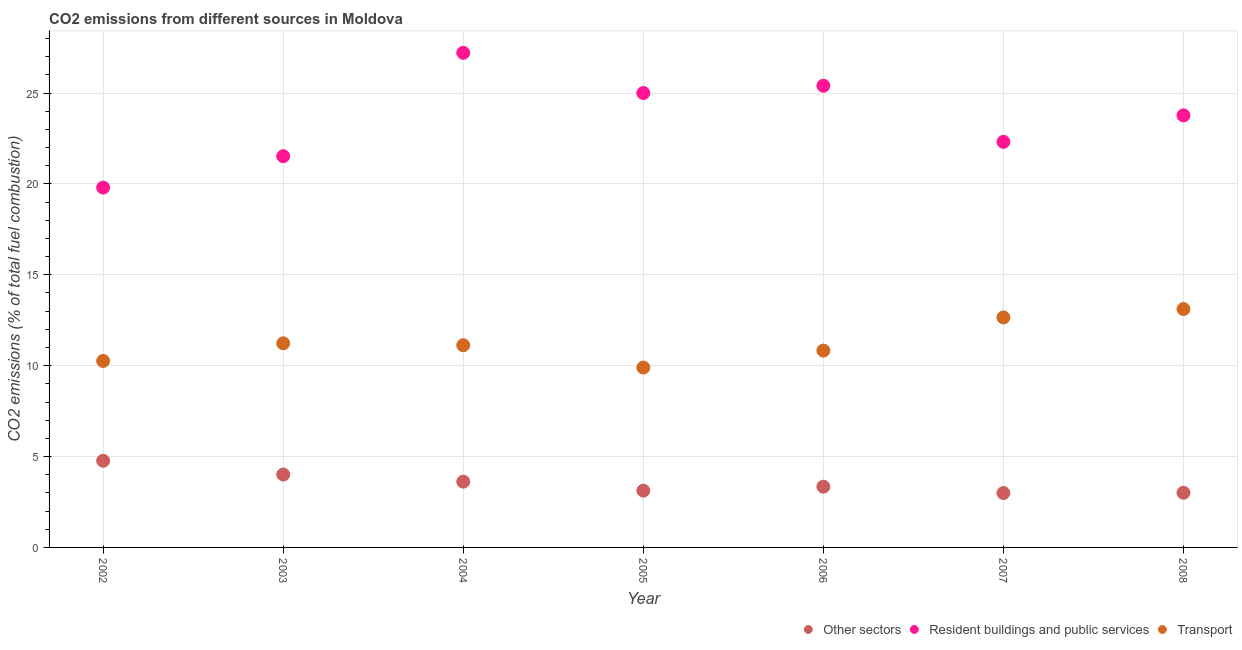How many different coloured dotlines are there?
Keep it short and to the point. 3. What is the percentage of co2 emissions from other sectors in 2004?
Give a very brief answer. 3.62. Across all years, what is the maximum percentage of co2 emissions from resident buildings and public services?
Your response must be concise. 27.21. Across all years, what is the minimum percentage of co2 emissions from other sectors?
Make the answer very short. 2.99. What is the total percentage of co2 emissions from transport in the graph?
Your response must be concise. 79.11. What is the difference between the percentage of co2 emissions from resident buildings and public services in 2004 and that in 2006?
Give a very brief answer. 1.81. What is the difference between the percentage of co2 emissions from resident buildings and public services in 2003 and the percentage of co2 emissions from transport in 2002?
Make the answer very short. 11.26. What is the average percentage of co2 emissions from other sectors per year?
Offer a terse response. 3.55. In the year 2004, what is the difference between the percentage of co2 emissions from other sectors and percentage of co2 emissions from resident buildings and public services?
Ensure brevity in your answer.  -23.59. What is the ratio of the percentage of co2 emissions from resident buildings and public services in 2003 to that in 2004?
Provide a succinct answer. 0.79. Is the percentage of co2 emissions from other sectors in 2004 less than that in 2005?
Offer a very short reply. No. Is the difference between the percentage of co2 emissions from transport in 2003 and 2006 greater than the difference between the percentage of co2 emissions from other sectors in 2003 and 2006?
Offer a very short reply. No. What is the difference between the highest and the second highest percentage of co2 emissions from transport?
Ensure brevity in your answer.  0.46. What is the difference between the highest and the lowest percentage of co2 emissions from resident buildings and public services?
Give a very brief answer. 7.41. Is it the case that in every year, the sum of the percentage of co2 emissions from other sectors and percentage of co2 emissions from resident buildings and public services is greater than the percentage of co2 emissions from transport?
Provide a short and direct response. Yes. Is the percentage of co2 emissions from resident buildings and public services strictly greater than the percentage of co2 emissions from transport over the years?
Give a very brief answer. Yes. How many years are there in the graph?
Offer a terse response. 7. What is the difference between two consecutive major ticks on the Y-axis?
Provide a succinct answer. 5. Are the values on the major ticks of Y-axis written in scientific E-notation?
Give a very brief answer. No. Does the graph contain any zero values?
Keep it short and to the point. No. Where does the legend appear in the graph?
Offer a terse response. Bottom right. How many legend labels are there?
Make the answer very short. 3. How are the legend labels stacked?
Keep it short and to the point. Horizontal. What is the title of the graph?
Give a very brief answer. CO2 emissions from different sources in Moldova. Does "Ireland" appear as one of the legend labels in the graph?
Make the answer very short. No. What is the label or title of the X-axis?
Your answer should be very brief. Year. What is the label or title of the Y-axis?
Provide a succinct answer. CO2 emissions (% of total fuel combustion). What is the CO2 emissions (% of total fuel combustion) in Other sectors in 2002?
Keep it short and to the point. 4.77. What is the CO2 emissions (% of total fuel combustion) in Resident buildings and public services in 2002?
Give a very brief answer. 19.8. What is the CO2 emissions (% of total fuel combustion) of Transport in 2002?
Make the answer very short. 10.26. What is the CO2 emissions (% of total fuel combustion) in Other sectors in 2003?
Your answer should be compact. 4.01. What is the CO2 emissions (% of total fuel combustion) of Resident buildings and public services in 2003?
Give a very brief answer. 21.52. What is the CO2 emissions (% of total fuel combustion) of Transport in 2003?
Provide a succinct answer. 11.23. What is the CO2 emissions (% of total fuel combustion) in Other sectors in 2004?
Give a very brief answer. 3.62. What is the CO2 emissions (% of total fuel combustion) in Resident buildings and public services in 2004?
Provide a succinct answer. 27.21. What is the CO2 emissions (% of total fuel combustion) of Transport in 2004?
Provide a short and direct response. 11.13. What is the CO2 emissions (% of total fuel combustion) of Other sectors in 2005?
Your response must be concise. 3.12. What is the CO2 emissions (% of total fuel combustion) in Resident buildings and public services in 2005?
Your answer should be very brief. 25. What is the CO2 emissions (% of total fuel combustion) of Transport in 2005?
Ensure brevity in your answer.  9.9. What is the CO2 emissions (% of total fuel combustion) of Other sectors in 2006?
Make the answer very short. 3.34. What is the CO2 emissions (% of total fuel combustion) in Resident buildings and public services in 2006?
Ensure brevity in your answer.  25.4. What is the CO2 emissions (% of total fuel combustion) in Transport in 2006?
Your answer should be very brief. 10.83. What is the CO2 emissions (% of total fuel combustion) in Other sectors in 2007?
Offer a terse response. 2.99. What is the CO2 emissions (% of total fuel combustion) of Resident buildings and public services in 2007?
Your answer should be very brief. 22.31. What is the CO2 emissions (% of total fuel combustion) in Transport in 2007?
Offer a terse response. 12.65. What is the CO2 emissions (% of total fuel combustion) in Other sectors in 2008?
Provide a short and direct response. 3.01. What is the CO2 emissions (% of total fuel combustion) of Resident buildings and public services in 2008?
Provide a succinct answer. 23.77. What is the CO2 emissions (% of total fuel combustion) in Transport in 2008?
Your answer should be compact. 13.11. Across all years, what is the maximum CO2 emissions (% of total fuel combustion) of Other sectors?
Offer a terse response. 4.77. Across all years, what is the maximum CO2 emissions (% of total fuel combustion) of Resident buildings and public services?
Your answer should be compact. 27.21. Across all years, what is the maximum CO2 emissions (% of total fuel combustion) of Transport?
Keep it short and to the point. 13.11. Across all years, what is the minimum CO2 emissions (% of total fuel combustion) in Other sectors?
Make the answer very short. 2.99. Across all years, what is the minimum CO2 emissions (% of total fuel combustion) of Resident buildings and public services?
Offer a very short reply. 19.8. Across all years, what is the minimum CO2 emissions (% of total fuel combustion) in Transport?
Offer a very short reply. 9.9. What is the total CO2 emissions (% of total fuel combustion) in Other sectors in the graph?
Make the answer very short. 24.86. What is the total CO2 emissions (% of total fuel combustion) in Resident buildings and public services in the graph?
Keep it short and to the point. 165.02. What is the total CO2 emissions (% of total fuel combustion) of Transport in the graph?
Your answer should be very brief. 79.11. What is the difference between the CO2 emissions (% of total fuel combustion) in Other sectors in 2002 and that in 2003?
Offer a very short reply. 0.76. What is the difference between the CO2 emissions (% of total fuel combustion) of Resident buildings and public services in 2002 and that in 2003?
Provide a succinct answer. -1.73. What is the difference between the CO2 emissions (% of total fuel combustion) of Transport in 2002 and that in 2003?
Your answer should be compact. -0.97. What is the difference between the CO2 emissions (% of total fuel combustion) in Other sectors in 2002 and that in 2004?
Your answer should be very brief. 1.15. What is the difference between the CO2 emissions (% of total fuel combustion) in Resident buildings and public services in 2002 and that in 2004?
Keep it short and to the point. -7.41. What is the difference between the CO2 emissions (% of total fuel combustion) in Transport in 2002 and that in 2004?
Give a very brief answer. -0.87. What is the difference between the CO2 emissions (% of total fuel combustion) of Other sectors in 2002 and that in 2005?
Offer a terse response. 1.64. What is the difference between the CO2 emissions (% of total fuel combustion) of Resident buildings and public services in 2002 and that in 2005?
Keep it short and to the point. -5.2. What is the difference between the CO2 emissions (% of total fuel combustion) in Transport in 2002 and that in 2005?
Provide a succinct answer. 0.36. What is the difference between the CO2 emissions (% of total fuel combustion) of Other sectors in 2002 and that in 2006?
Give a very brief answer. 1.43. What is the difference between the CO2 emissions (% of total fuel combustion) of Resident buildings and public services in 2002 and that in 2006?
Offer a terse response. -5.6. What is the difference between the CO2 emissions (% of total fuel combustion) of Transport in 2002 and that in 2006?
Keep it short and to the point. -0.57. What is the difference between the CO2 emissions (% of total fuel combustion) in Other sectors in 2002 and that in 2007?
Your answer should be very brief. 1.78. What is the difference between the CO2 emissions (% of total fuel combustion) in Resident buildings and public services in 2002 and that in 2007?
Offer a very short reply. -2.52. What is the difference between the CO2 emissions (% of total fuel combustion) in Transport in 2002 and that in 2007?
Give a very brief answer. -2.39. What is the difference between the CO2 emissions (% of total fuel combustion) in Other sectors in 2002 and that in 2008?
Your answer should be very brief. 1.76. What is the difference between the CO2 emissions (% of total fuel combustion) of Resident buildings and public services in 2002 and that in 2008?
Offer a very short reply. -3.97. What is the difference between the CO2 emissions (% of total fuel combustion) in Transport in 2002 and that in 2008?
Your answer should be compact. -2.85. What is the difference between the CO2 emissions (% of total fuel combustion) of Other sectors in 2003 and that in 2004?
Offer a very short reply. 0.39. What is the difference between the CO2 emissions (% of total fuel combustion) in Resident buildings and public services in 2003 and that in 2004?
Give a very brief answer. -5.69. What is the difference between the CO2 emissions (% of total fuel combustion) of Transport in 2003 and that in 2004?
Your answer should be very brief. 0.1. What is the difference between the CO2 emissions (% of total fuel combustion) of Other sectors in 2003 and that in 2005?
Make the answer very short. 0.89. What is the difference between the CO2 emissions (% of total fuel combustion) of Resident buildings and public services in 2003 and that in 2005?
Provide a short and direct response. -3.48. What is the difference between the CO2 emissions (% of total fuel combustion) in Transport in 2003 and that in 2005?
Provide a short and direct response. 1.33. What is the difference between the CO2 emissions (% of total fuel combustion) of Other sectors in 2003 and that in 2006?
Provide a succinct answer. 0.67. What is the difference between the CO2 emissions (% of total fuel combustion) of Resident buildings and public services in 2003 and that in 2006?
Provide a short and direct response. -3.88. What is the difference between the CO2 emissions (% of total fuel combustion) in Transport in 2003 and that in 2006?
Give a very brief answer. 0.4. What is the difference between the CO2 emissions (% of total fuel combustion) of Other sectors in 2003 and that in 2007?
Give a very brief answer. 1.02. What is the difference between the CO2 emissions (% of total fuel combustion) of Resident buildings and public services in 2003 and that in 2007?
Offer a terse response. -0.79. What is the difference between the CO2 emissions (% of total fuel combustion) in Transport in 2003 and that in 2007?
Give a very brief answer. -1.42. What is the difference between the CO2 emissions (% of total fuel combustion) of Other sectors in 2003 and that in 2008?
Ensure brevity in your answer.  1.01. What is the difference between the CO2 emissions (% of total fuel combustion) in Resident buildings and public services in 2003 and that in 2008?
Give a very brief answer. -2.25. What is the difference between the CO2 emissions (% of total fuel combustion) of Transport in 2003 and that in 2008?
Make the answer very short. -1.88. What is the difference between the CO2 emissions (% of total fuel combustion) in Other sectors in 2004 and that in 2005?
Give a very brief answer. 0.49. What is the difference between the CO2 emissions (% of total fuel combustion) in Resident buildings and public services in 2004 and that in 2005?
Ensure brevity in your answer.  2.21. What is the difference between the CO2 emissions (% of total fuel combustion) in Transport in 2004 and that in 2005?
Ensure brevity in your answer.  1.23. What is the difference between the CO2 emissions (% of total fuel combustion) in Other sectors in 2004 and that in 2006?
Provide a succinct answer. 0.28. What is the difference between the CO2 emissions (% of total fuel combustion) in Resident buildings and public services in 2004 and that in 2006?
Give a very brief answer. 1.81. What is the difference between the CO2 emissions (% of total fuel combustion) in Transport in 2004 and that in 2006?
Ensure brevity in your answer.  0.3. What is the difference between the CO2 emissions (% of total fuel combustion) in Other sectors in 2004 and that in 2007?
Make the answer very short. 0.63. What is the difference between the CO2 emissions (% of total fuel combustion) of Resident buildings and public services in 2004 and that in 2007?
Provide a short and direct response. 4.9. What is the difference between the CO2 emissions (% of total fuel combustion) of Transport in 2004 and that in 2007?
Ensure brevity in your answer.  -1.53. What is the difference between the CO2 emissions (% of total fuel combustion) of Other sectors in 2004 and that in 2008?
Your response must be concise. 0.61. What is the difference between the CO2 emissions (% of total fuel combustion) in Resident buildings and public services in 2004 and that in 2008?
Offer a very short reply. 3.44. What is the difference between the CO2 emissions (% of total fuel combustion) of Transport in 2004 and that in 2008?
Provide a succinct answer. -1.99. What is the difference between the CO2 emissions (% of total fuel combustion) in Other sectors in 2005 and that in 2006?
Keep it short and to the point. -0.22. What is the difference between the CO2 emissions (% of total fuel combustion) of Resident buildings and public services in 2005 and that in 2006?
Give a very brief answer. -0.4. What is the difference between the CO2 emissions (% of total fuel combustion) of Transport in 2005 and that in 2006?
Provide a short and direct response. -0.93. What is the difference between the CO2 emissions (% of total fuel combustion) in Other sectors in 2005 and that in 2007?
Your answer should be very brief. 0.13. What is the difference between the CO2 emissions (% of total fuel combustion) of Resident buildings and public services in 2005 and that in 2007?
Offer a terse response. 2.69. What is the difference between the CO2 emissions (% of total fuel combustion) in Transport in 2005 and that in 2007?
Give a very brief answer. -2.76. What is the difference between the CO2 emissions (% of total fuel combustion) of Other sectors in 2005 and that in 2008?
Ensure brevity in your answer.  0.12. What is the difference between the CO2 emissions (% of total fuel combustion) in Resident buildings and public services in 2005 and that in 2008?
Keep it short and to the point. 1.23. What is the difference between the CO2 emissions (% of total fuel combustion) in Transport in 2005 and that in 2008?
Your answer should be very brief. -3.22. What is the difference between the CO2 emissions (% of total fuel combustion) of Other sectors in 2006 and that in 2007?
Offer a terse response. 0.35. What is the difference between the CO2 emissions (% of total fuel combustion) in Resident buildings and public services in 2006 and that in 2007?
Ensure brevity in your answer.  3.09. What is the difference between the CO2 emissions (% of total fuel combustion) of Transport in 2006 and that in 2007?
Your answer should be compact. -1.82. What is the difference between the CO2 emissions (% of total fuel combustion) in Other sectors in 2006 and that in 2008?
Provide a short and direct response. 0.34. What is the difference between the CO2 emissions (% of total fuel combustion) in Resident buildings and public services in 2006 and that in 2008?
Offer a terse response. 1.63. What is the difference between the CO2 emissions (% of total fuel combustion) of Transport in 2006 and that in 2008?
Your answer should be very brief. -2.29. What is the difference between the CO2 emissions (% of total fuel combustion) of Other sectors in 2007 and that in 2008?
Your answer should be compact. -0.01. What is the difference between the CO2 emissions (% of total fuel combustion) in Resident buildings and public services in 2007 and that in 2008?
Provide a succinct answer. -1.46. What is the difference between the CO2 emissions (% of total fuel combustion) in Transport in 2007 and that in 2008?
Give a very brief answer. -0.46. What is the difference between the CO2 emissions (% of total fuel combustion) in Other sectors in 2002 and the CO2 emissions (% of total fuel combustion) in Resident buildings and public services in 2003?
Offer a terse response. -16.76. What is the difference between the CO2 emissions (% of total fuel combustion) of Other sectors in 2002 and the CO2 emissions (% of total fuel combustion) of Transport in 2003?
Offer a very short reply. -6.46. What is the difference between the CO2 emissions (% of total fuel combustion) of Resident buildings and public services in 2002 and the CO2 emissions (% of total fuel combustion) of Transport in 2003?
Your response must be concise. 8.57. What is the difference between the CO2 emissions (% of total fuel combustion) in Other sectors in 2002 and the CO2 emissions (% of total fuel combustion) in Resident buildings and public services in 2004?
Offer a very short reply. -22.44. What is the difference between the CO2 emissions (% of total fuel combustion) of Other sectors in 2002 and the CO2 emissions (% of total fuel combustion) of Transport in 2004?
Keep it short and to the point. -6.36. What is the difference between the CO2 emissions (% of total fuel combustion) in Resident buildings and public services in 2002 and the CO2 emissions (% of total fuel combustion) in Transport in 2004?
Your response must be concise. 8.67. What is the difference between the CO2 emissions (% of total fuel combustion) of Other sectors in 2002 and the CO2 emissions (% of total fuel combustion) of Resident buildings and public services in 2005?
Your response must be concise. -20.23. What is the difference between the CO2 emissions (% of total fuel combustion) in Other sectors in 2002 and the CO2 emissions (% of total fuel combustion) in Transport in 2005?
Give a very brief answer. -5.13. What is the difference between the CO2 emissions (% of total fuel combustion) of Resident buildings and public services in 2002 and the CO2 emissions (% of total fuel combustion) of Transport in 2005?
Keep it short and to the point. 9.9. What is the difference between the CO2 emissions (% of total fuel combustion) of Other sectors in 2002 and the CO2 emissions (% of total fuel combustion) of Resident buildings and public services in 2006?
Provide a short and direct response. -20.63. What is the difference between the CO2 emissions (% of total fuel combustion) in Other sectors in 2002 and the CO2 emissions (% of total fuel combustion) in Transport in 2006?
Offer a very short reply. -6.06. What is the difference between the CO2 emissions (% of total fuel combustion) in Resident buildings and public services in 2002 and the CO2 emissions (% of total fuel combustion) in Transport in 2006?
Make the answer very short. 8.97. What is the difference between the CO2 emissions (% of total fuel combustion) of Other sectors in 2002 and the CO2 emissions (% of total fuel combustion) of Resident buildings and public services in 2007?
Your answer should be very brief. -17.54. What is the difference between the CO2 emissions (% of total fuel combustion) in Other sectors in 2002 and the CO2 emissions (% of total fuel combustion) in Transport in 2007?
Give a very brief answer. -7.88. What is the difference between the CO2 emissions (% of total fuel combustion) in Resident buildings and public services in 2002 and the CO2 emissions (% of total fuel combustion) in Transport in 2007?
Give a very brief answer. 7.14. What is the difference between the CO2 emissions (% of total fuel combustion) of Other sectors in 2002 and the CO2 emissions (% of total fuel combustion) of Resident buildings and public services in 2008?
Your answer should be compact. -19. What is the difference between the CO2 emissions (% of total fuel combustion) of Other sectors in 2002 and the CO2 emissions (% of total fuel combustion) of Transport in 2008?
Give a very brief answer. -8.35. What is the difference between the CO2 emissions (% of total fuel combustion) in Resident buildings and public services in 2002 and the CO2 emissions (% of total fuel combustion) in Transport in 2008?
Give a very brief answer. 6.68. What is the difference between the CO2 emissions (% of total fuel combustion) in Other sectors in 2003 and the CO2 emissions (% of total fuel combustion) in Resident buildings and public services in 2004?
Offer a very short reply. -23.2. What is the difference between the CO2 emissions (% of total fuel combustion) of Other sectors in 2003 and the CO2 emissions (% of total fuel combustion) of Transport in 2004?
Offer a very short reply. -7.12. What is the difference between the CO2 emissions (% of total fuel combustion) of Resident buildings and public services in 2003 and the CO2 emissions (% of total fuel combustion) of Transport in 2004?
Your answer should be compact. 10.4. What is the difference between the CO2 emissions (% of total fuel combustion) in Other sectors in 2003 and the CO2 emissions (% of total fuel combustion) in Resident buildings and public services in 2005?
Your answer should be compact. -20.99. What is the difference between the CO2 emissions (% of total fuel combustion) of Other sectors in 2003 and the CO2 emissions (% of total fuel combustion) of Transport in 2005?
Your response must be concise. -5.89. What is the difference between the CO2 emissions (% of total fuel combustion) of Resident buildings and public services in 2003 and the CO2 emissions (% of total fuel combustion) of Transport in 2005?
Make the answer very short. 11.63. What is the difference between the CO2 emissions (% of total fuel combustion) of Other sectors in 2003 and the CO2 emissions (% of total fuel combustion) of Resident buildings and public services in 2006?
Ensure brevity in your answer.  -21.39. What is the difference between the CO2 emissions (% of total fuel combustion) of Other sectors in 2003 and the CO2 emissions (% of total fuel combustion) of Transport in 2006?
Give a very brief answer. -6.82. What is the difference between the CO2 emissions (% of total fuel combustion) of Resident buildings and public services in 2003 and the CO2 emissions (% of total fuel combustion) of Transport in 2006?
Give a very brief answer. 10.7. What is the difference between the CO2 emissions (% of total fuel combustion) in Other sectors in 2003 and the CO2 emissions (% of total fuel combustion) in Resident buildings and public services in 2007?
Give a very brief answer. -18.3. What is the difference between the CO2 emissions (% of total fuel combustion) of Other sectors in 2003 and the CO2 emissions (% of total fuel combustion) of Transport in 2007?
Your answer should be compact. -8.64. What is the difference between the CO2 emissions (% of total fuel combustion) of Resident buildings and public services in 2003 and the CO2 emissions (% of total fuel combustion) of Transport in 2007?
Keep it short and to the point. 8.87. What is the difference between the CO2 emissions (% of total fuel combustion) of Other sectors in 2003 and the CO2 emissions (% of total fuel combustion) of Resident buildings and public services in 2008?
Your answer should be very brief. -19.76. What is the difference between the CO2 emissions (% of total fuel combustion) of Other sectors in 2003 and the CO2 emissions (% of total fuel combustion) of Transport in 2008?
Ensure brevity in your answer.  -9.1. What is the difference between the CO2 emissions (% of total fuel combustion) in Resident buildings and public services in 2003 and the CO2 emissions (% of total fuel combustion) in Transport in 2008?
Your answer should be very brief. 8.41. What is the difference between the CO2 emissions (% of total fuel combustion) of Other sectors in 2004 and the CO2 emissions (% of total fuel combustion) of Resident buildings and public services in 2005?
Offer a very short reply. -21.38. What is the difference between the CO2 emissions (% of total fuel combustion) of Other sectors in 2004 and the CO2 emissions (% of total fuel combustion) of Transport in 2005?
Ensure brevity in your answer.  -6.28. What is the difference between the CO2 emissions (% of total fuel combustion) in Resident buildings and public services in 2004 and the CO2 emissions (% of total fuel combustion) in Transport in 2005?
Keep it short and to the point. 17.32. What is the difference between the CO2 emissions (% of total fuel combustion) of Other sectors in 2004 and the CO2 emissions (% of total fuel combustion) of Resident buildings and public services in 2006?
Ensure brevity in your answer.  -21.78. What is the difference between the CO2 emissions (% of total fuel combustion) in Other sectors in 2004 and the CO2 emissions (% of total fuel combustion) in Transport in 2006?
Make the answer very short. -7.21. What is the difference between the CO2 emissions (% of total fuel combustion) of Resident buildings and public services in 2004 and the CO2 emissions (% of total fuel combustion) of Transport in 2006?
Provide a succinct answer. 16.38. What is the difference between the CO2 emissions (% of total fuel combustion) of Other sectors in 2004 and the CO2 emissions (% of total fuel combustion) of Resident buildings and public services in 2007?
Offer a terse response. -18.69. What is the difference between the CO2 emissions (% of total fuel combustion) in Other sectors in 2004 and the CO2 emissions (% of total fuel combustion) in Transport in 2007?
Give a very brief answer. -9.03. What is the difference between the CO2 emissions (% of total fuel combustion) of Resident buildings and public services in 2004 and the CO2 emissions (% of total fuel combustion) of Transport in 2007?
Give a very brief answer. 14.56. What is the difference between the CO2 emissions (% of total fuel combustion) in Other sectors in 2004 and the CO2 emissions (% of total fuel combustion) in Resident buildings and public services in 2008?
Your answer should be very brief. -20.15. What is the difference between the CO2 emissions (% of total fuel combustion) of Other sectors in 2004 and the CO2 emissions (% of total fuel combustion) of Transport in 2008?
Ensure brevity in your answer.  -9.5. What is the difference between the CO2 emissions (% of total fuel combustion) in Resident buildings and public services in 2004 and the CO2 emissions (% of total fuel combustion) in Transport in 2008?
Provide a short and direct response. 14.1. What is the difference between the CO2 emissions (% of total fuel combustion) in Other sectors in 2005 and the CO2 emissions (% of total fuel combustion) in Resident buildings and public services in 2006?
Your answer should be compact. -22.28. What is the difference between the CO2 emissions (% of total fuel combustion) in Other sectors in 2005 and the CO2 emissions (% of total fuel combustion) in Transport in 2006?
Make the answer very short. -7.7. What is the difference between the CO2 emissions (% of total fuel combustion) of Resident buildings and public services in 2005 and the CO2 emissions (% of total fuel combustion) of Transport in 2006?
Give a very brief answer. 14.17. What is the difference between the CO2 emissions (% of total fuel combustion) in Other sectors in 2005 and the CO2 emissions (% of total fuel combustion) in Resident buildings and public services in 2007?
Offer a terse response. -19.19. What is the difference between the CO2 emissions (% of total fuel combustion) of Other sectors in 2005 and the CO2 emissions (% of total fuel combustion) of Transport in 2007?
Your answer should be compact. -9.53. What is the difference between the CO2 emissions (% of total fuel combustion) of Resident buildings and public services in 2005 and the CO2 emissions (% of total fuel combustion) of Transport in 2007?
Keep it short and to the point. 12.35. What is the difference between the CO2 emissions (% of total fuel combustion) in Other sectors in 2005 and the CO2 emissions (% of total fuel combustion) in Resident buildings and public services in 2008?
Make the answer very short. -20.65. What is the difference between the CO2 emissions (% of total fuel combustion) in Other sectors in 2005 and the CO2 emissions (% of total fuel combustion) in Transport in 2008?
Your response must be concise. -9.99. What is the difference between the CO2 emissions (% of total fuel combustion) in Resident buildings and public services in 2005 and the CO2 emissions (% of total fuel combustion) in Transport in 2008?
Your answer should be compact. 11.89. What is the difference between the CO2 emissions (% of total fuel combustion) of Other sectors in 2006 and the CO2 emissions (% of total fuel combustion) of Resident buildings and public services in 2007?
Provide a short and direct response. -18.97. What is the difference between the CO2 emissions (% of total fuel combustion) in Other sectors in 2006 and the CO2 emissions (% of total fuel combustion) in Transport in 2007?
Provide a short and direct response. -9.31. What is the difference between the CO2 emissions (% of total fuel combustion) in Resident buildings and public services in 2006 and the CO2 emissions (% of total fuel combustion) in Transport in 2007?
Your response must be concise. 12.75. What is the difference between the CO2 emissions (% of total fuel combustion) in Other sectors in 2006 and the CO2 emissions (% of total fuel combustion) in Resident buildings and public services in 2008?
Your answer should be compact. -20.43. What is the difference between the CO2 emissions (% of total fuel combustion) of Other sectors in 2006 and the CO2 emissions (% of total fuel combustion) of Transport in 2008?
Make the answer very short. -9.77. What is the difference between the CO2 emissions (% of total fuel combustion) of Resident buildings and public services in 2006 and the CO2 emissions (% of total fuel combustion) of Transport in 2008?
Your answer should be compact. 12.29. What is the difference between the CO2 emissions (% of total fuel combustion) of Other sectors in 2007 and the CO2 emissions (% of total fuel combustion) of Resident buildings and public services in 2008?
Offer a very short reply. -20.78. What is the difference between the CO2 emissions (% of total fuel combustion) of Other sectors in 2007 and the CO2 emissions (% of total fuel combustion) of Transport in 2008?
Offer a terse response. -10.12. What is the difference between the CO2 emissions (% of total fuel combustion) in Resident buildings and public services in 2007 and the CO2 emissions (% of total fuel combustion) in Transport in 2008?
Keep it short and to the point. 9.2. What is the average CO2 emissions (% of total fuel combustion) in Other sectors per year?
Make the answer very short. 3.55. What is the average CO2 emissions (% of total fuel combustion) of Resident buildings and public services per year?
Your answer should be very brief. 23.57. What is the average CO2 emissions (% of total fuel combustion) of Transport per year?
Provide a succinct answer. 11.3. In the year 2002, what is the difference between the CO2 emissions (% of total fuel combustion) of Other sectors and CO2 emissions (% of total fuel combustion) of Resident buildings and public services?
Provide a short and direct response. -15.03. In the year 2002, what is the difference between the CO2 emissions (% of total fuel combustion) in Other sectors and CO2 emissions (% of total fuel combustion) in Transport?
Offer a terse response. -5.49. In the year 2002, what is the difference between the CO2 emissions (% of total fuel combustion) in Resident buildings and public services and CO2 emissions (% of total fuel combustion) in Transport?
Provide a succinct answer. 9.54. In the year 2003, what is the difference between the CO2 emissions (% of total fuel combustion) of Other sectors and CO2 emissions (% of total fuel combustion) of Resident buildings and public services?
Your answer should be compact. -17.51. In the year 2003, what is the difference between the CO2 emissions (% of total fuel combustion) of Other sectors and CO2 emissions (% of total fuel combustion) of Transport?
Give a very brief answer. -7.22. In the year 2003, what is the difference between the CO2 emissions (% of total fuel combustion) in Resident buildings and public services and CO2 emissions (% of total fuel combustion) in Transport?
Offer a very short reply. 10.29. In the year 2004, what is the difference between the CO2 emissions (% of total fuel combustion) in Other sectors and CO2 emissions (% of total fuel combustion) in Resident buildings and public services?
Your answer should be compact. -23.59. In the year 2004, what is the difference between the CO2 emissions (% of total fuel combustion) in Other sectors and CO2 emissions (% of total fuel combustion) in Transport?
Provide a succinct answer. -7.51. In the year 2004, what is the difference between the CO2 emissions (% of total fuel combustion) of Resident buildings and public services and CO2 emissions (% of total fuel combustion) of Transport?
Keep it short and to the point. 16.09. In the year 2005, what is the difference between the CO2 emissions (% of total fuel combustion) in Other sectors and CO2 emissions (% of total fuel combustion) in Resident buildings and public services?
Ensure brevity in your answer.  -21.88. In the year 2005, what is the difference between the CO2 emissions (% of total fuel combustion) in Other sectors and CO2 emissions (% of total fuel combustion) in Transport?
Provide a short and direct response. -6.77. In the year 2005, what is the difference between the CO2 emissions (% of total fuel combustion) in Resident buildings and public services and CO2 emissions (% of total fuel combustion) in Transport?
Your answer should be compact. 15.1. In the year 2006, what is the difference between the CO2 emissions (% of total fuel combustion) of Other sectors and CO2 emissions (% of total fuel combustion) of Resident buildings and public services?
Offer a very short reply. -22.06. In the year 2006, what is the difference between the CO2 emissions (% of total fuel combustion) in Other sectors and CO2 emissions (% of total fuel combustion) in Transport?
Keep it short and to the point. -7.49. In the year 2006, what is the difference between the CO2 emissions (% of total fuel combustion) of Resident buildings and public services and CO2 emissions (% of total fuel combustion) of Transport?
Your answer should be compact. 14.57. In the year 2007, what is the difference between the CO2 emissions (% of total fuel combustion) of Other sectors and CO2 emissions (% of total fuel combustion) of Resident buildings and public services?
Offer a terse response. -19.32. In the year 2007, what is the difference between the CO2 emissions (% of total fuel combustion) of Other sectors and CO2 emissions (% of total fuel combustion) of Transport?
Ensure brevity in your answer.  -9.66. In the year 2007, what is the difference between the CO2 emissions (% of total fuel combustion) in Resident buildings and public services and CO2 emissions (% of total fuel combustion) in Transport?
Give a very brief answer. 9.66. In the year 2008, what is the difference between the CO2 emissions (% of total fuel combustion) in Other sectors and CO2 emissions (% of total fuel combustion) in Resident buildings and public services?
Offer a terse response. -20.77. In the year 2008, what is the difference between the CO2 emissions (% of total fuel combustion) of Other sectors and CO2 emissions (% of total fuel combustion) of Transport?
Offer a very short reply. -10.11. In the year 2008, what is the difference between the CO2 emissions (% of total fuel combustion) of Resident buildings and public services and CO2 emissions (% of total fuel combustion) of Transport?
Your answer should be compact. 10.66. What is the ratio of the CO2 emissions (% of total fuel combustion) in Other sectors in 2002 to that in 2003?
Your response must be concise. 1.19. What is the ratio of the CO2 emissions (% of total fuel combustion) of Resident buildings and public services in 2002 to that in 2003?
Provide a short and direct response. 0.92. What is the ratio of the CO2 emissions (% of total fuel combustion) in Transport in 2002 to that in 2003?
Your response must be concise. 0.91. What is the ratio of the CO2 emissions (% of total fuel combustion) of Other sectors in 2002 to that in 2004?
Make the answer very short. 1.32. What is the ratio of the CO2 emissions (% of total fuel combustion) of Resident buildings and public services in 2002 to that in 2004?
Ensure brevity in your answer.  0.73. What is the ratio of the CO2 emissions (% of total fuel combustion) of Transport in 2002 to that in 2004?
Offer a terse response. 0.92. What is the ratio of the CO2 emissions (% of total fuel combustion) in Other sectors in 2002 to that in 2005?
Offer a terse response. 1.53. What is the ratio of the CO2 emissions (% of total fuel combustion) of Resident buildings and public services in 2002 to that in 2005?
Ensure brevity in your answer.  0.79. What is the ratio of the CO2 emissions (% of total fuel combustion) of Transport in 2002 to that in 2005?
Offer a terse response. 1.04. What is the ratio of the CO2 emissions (% of total fuel combustion) of Other sectors in 2002 to that in 2006?
Your answer should be very brief. 1.43. What is the ratio of the CO2 emissions (% of total fuel combustion) in Resident buildings and public services in 2002 to that in 2006?
Provide a short and direct response. 0.78. What is the ratio of the CO2 emissions (% of total fuel combustion) in Transport in 2002 to that in 2006?
Offer a very short reply. 0.95. What is the ratio of the CO2 emissions (% of total fuel combustion) in Other sectors in 2002 to that in 2007?
Your answer should be compact. 1.59. What is the ratio of the CO2 emissions (% of total fuel combustion) in Resident buildings and public services in 2002 to that in 2007?
Give a very brief answer. 0.89. What is the ratio of the CO2 emissions (% of total fuel combustion) of Transport in 2002 to that in 2007?
Your response must be concise. 0.81. What is the ratio of the CO2 emissions (% of total fuel combustion) in Other sectors in 2002 to that in 2008?
Offer a very short reply. 1.59. What is the ratio of the CO2 emissions (% of total fuel combustion) in Resident buildings and public services in 2002 to that in 2008?
Give a very brief answer. 0.83. What is the ratio of the CO2 emissions (% of total fuel combustion) of Transport in 2002 to that in 2008?
Ensure brevity in your answer.  0.78. What is the ratio of the CO2 emissions (% of total fuel combustion) in Other sectors in 2003 to that in 2004?
Provide a succinct answer. 1.11. What is the ratio of the CO2 emissions (% of total fuel combustion) of Resident buildings and public services in 2003 to that in 2004?
Offer a terse response. 0.79. What is the ratio of the CO2 emissions (% of total fuel combustion) in Transport in 2003 to that in 2004?
Your response must be concise. 1.01. What is the ratio of the CO2 emissions (% of total fuel combustion) in Other sectors in 2003 to that in 2005?
Keep it short and to the point. 1.28. What is the ratio of the CO2 emissions (% of total fuel combustion) of Resident buildings and public services in 2003 to that in 2005?
Offer a very short reply. 0.86. What is the ratio of the CO2 emissions (% of total fuel combustion) of Transport in 2003 to that in 2005?
Offer a very short reply. 1.13. What is the ratio of the CO2 emissions (% of total fuel combustion) of Other sectors in 2003 to that in 2006?
Offer a terse response. 1.2. What is the ratio of the CO2 emissions (% of total fuel combustion) of Resident buildings and public services in 2003 to that in 2006?
Give a very brief answer. 0.85. What is the ratio of the CO2 emissions (% of total fuel combustion) of Other sectors in 2003 to that in 2007?
Provide a succinct answer. 1.34. What is the ratio of the CO2 emissions (% of total fuel combustion) in Resident buildings and public services in 2003 to that in 2007?
Offer a very short reply. 0.96. What is the ratio of the CO2 emissions (% of total fuel combustion) in Transport in 2003 to that in 2007?
Keep it short and to the point. 0.89. What is the ratio of the CO2 emissions (% of total fuel combustion) of Other sectors in 2003 to that in 2008?
Offer a terse response. 1.33. What is the ratio of the CO2 emissions (% of total fuel combustion) in Resident buildings and public services in 2003 to that in 2008?
Your response must be concise. 0.91. What is the ratio of the CO2 emissions (% of total fuel combustion) in Transport in 2003 to that in 2008?
Your response must be concise. 0.86. What is the ratio of the CO2 emissions (% of total fuel combustion) of Other sectors in 2004 to that in 2005?
Your response must be concise. 1.16. What is the ratio of the CO2 emissions (% of total fuel combustion) of Resident buildings and public services in 2004 to that in 2005?
Your answer should be compact. 1.09. What is the ratio of the CO2 emissions (% of total fuel combustion) of Transport in 2004 to that in 2005?
Your answer should be very brief. 1.12. What is the ratio of the CO2 emissions (% of total fuel combustion) of Other sectors in 2004 to that in 2006?
Your answer should be very brief. 1.08. What is the ratio of the CO2 emissions (% of total fuel combustion) in Resident buildings and public services in 2004 to that in 2006?
Your answer should be very brief. 1.07. What is the ratio of the CO2 emissions (% of total fuel combustion) of Transport in 2004 to that in 2006?
Ensure brevity in your answer.  1.03. What is the ratio of the CO2 emissions (% of total fuel combustion) in Other sectors in 2004 to that in 2007?
Your answer should be very brief. 1.21. What is the ratio of the CO2 emissions (% of total fuel combustion) in Resident buildings and public services in 2004 to that in 2007?
Provide a short and direct response. 1.22. What is the ratio of the CO2 emissions (% of total fuel combustion) in Transport in 2004 to that in 2007?
Your response must be concise. 0.88. What is the ratio of the CO2 emissions (% of total fuel combustion) in Other sectors in 2004 to that in 2008?
Ensure brevity in your answer.  1.2. What is the ratio of the CO2 emissions (% of total fuel combustion) in Resident buildings and public services in 2004 to that in 2008?
Your answer should be very brief. 1.14. What is the ratio of the CO2 emissions (% of total fuel combustion) in Transport in 2004 to that in 2008?
Offer a very short reply. 0.85. What is the ratio of the CO2 emissions (% of total fuel combustion) of Other sectors in 2005 to that in 2006?
Provide a succinct answer. 0.94. What is the ratio of the CO2 emissions (% of total fuel combustion) of Resident buildings and public services in 2005 to that in 2006?
Your answer should be compact. 0.98. What is the ratio of the CO2 emissions (% of total fuel combustion) in Transport in 2005 to that in 2006?
Offer a terse response. 0.91. What is the ratio of the CO2 emissions (% of total fuel combustion) in Other sectors in 2005 to that in 2007?
Ensure brevity in your answer.  1.04. What is the ratio of the CO2 emissions (% of total fuel combustion) of Resident buildings and public services in 2005 to that in 2007?
Provide a short and direct response. 1.12. What is the ratio of the CO2 emissions (% of total fuel combustion) in Transport in 2005 to that in 2007?
Offer a very short reply. 0.78. What is the ratio of the CO2 emissions (% of total fuel combustion) in Other sectors in 2005 to that in 2008?
Provide a short and direct response. 1.04. What is the ratio of the CO2 emissions (% of total fuel combustion) in Resident buildings and public services in 2005 to that in 2008?
Offer a terse response. 1.05. What is the ratio of the CO2 emissions (% of total fuel combustion) of Transport in 2005 to that in 2008?
Ensure brevity in your answer.  0.75. What is the ratio of the CO2 emissions (% of total fuel combustion) of Other sectors in 2006 to that in 2007?
Provide a short and direct response. 1.12. What is the ratio of the CO2 emissions (% of total fuel combustion) of Resident buildings and public services in 2006 to that in 2007?
Provide a succinct answer. 1.14. What is the ratio of the CO2 emissions (% of total fuel combustion) in Transport in 2006 to that in 2007?
Keep it short and to the point. 0.86. What is the ratio of the CO2 emissions (% of total fuel combustion) in Other sectors in 2006 to that in 2008?
Your response must be concise. 1.11. What is the ratio of the CO2 emissions (% of total fuel combustion) in Resident buildings and public services in 2006 to that in 2008?
Offer a very short reply. 1.07. What is the ratio of the CO2 emissions (% of total fuel combustion) in Transport in 2006 to that in 2008?
Give a very brief answer. 0.83. What is the ratio of the CO2 emissions (% of total fuel combustion) of Resident buildings and public services in 2007 to that in 2008?
Your answer should be compact. 0.94. What is the ratio of the CO2 emissions (% of total fuel combustion) of Transport in 2007 to that in 2008?
Ensure brevity in your answer.  0.96. What is the difference between the highest and the second highest CO2 emissions (% of total fuel combustion) in Other sectors?
Keep it short and to the point. 0.76. What is the difference between the highest and the second highest CO2 emissions (% of total fuel combustion) of Resident buildings and public services?
Provide a short and direct response. 1.81. What is the difference between the highest and the second highest CO2 emissions (% of total fuel combustion) of Transport?
Keep it short and to the point. 0.46. What is the difference between the highest and the lowest CO2 emissions (% of total fuel combustion) in Other sectors?
Ensure brevity in your answer.  1.78. What is the difference between the highest and the lowest CO2 emissions (% of total fuel combustion) in Resident buildings and public services?
Offer a very short reply. 7.41. What is the difference between the highest and the lowest CO2 emissions (% of total fuel combustion) in Transport?
Provide a succinct answer. 3.22. 